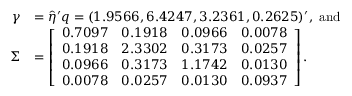<formula> <loc_0><loc_0><loc_500><loc_500>\begin{array} { r l } { \gamma } & { = \hat { \eta } ^ { \prime } q = ( 1 . 9 5 6 6 , 6 . 4 2 4 7 , 3 . 2 3 6 1 , 0 . 2 6 2 5 ) ^ { \prime } , a n d } \\ { \Sigma } & { = \left [ \begin{array} { l l l l } { 0 . 7 0 9 7 } & { 0 . 1 9 1 8 } & { 0 . 0 9 6 6 } & { 0 . 0 0 7 8 } \\ { 0 . 1 9 1 8 } & { 2 . 3 3 0 2 } & { 0 . 3 1 7 3 } & { 0 . 0 2 5 7 } \\ { 0 . 0 9 6 6 } & { 0 . 3 1 7 3 } & { 1 . 1 7 4 2 } & { 0 . 0 1 3 0 } \\ { 0 . 0 0 7 8 } & { 0 . 0 2 5 7 } & { 0 . 0 1 3 0 } & { 0 . 0 9 3 7 } \end{array} \right ] . } \end{array}</formula> 